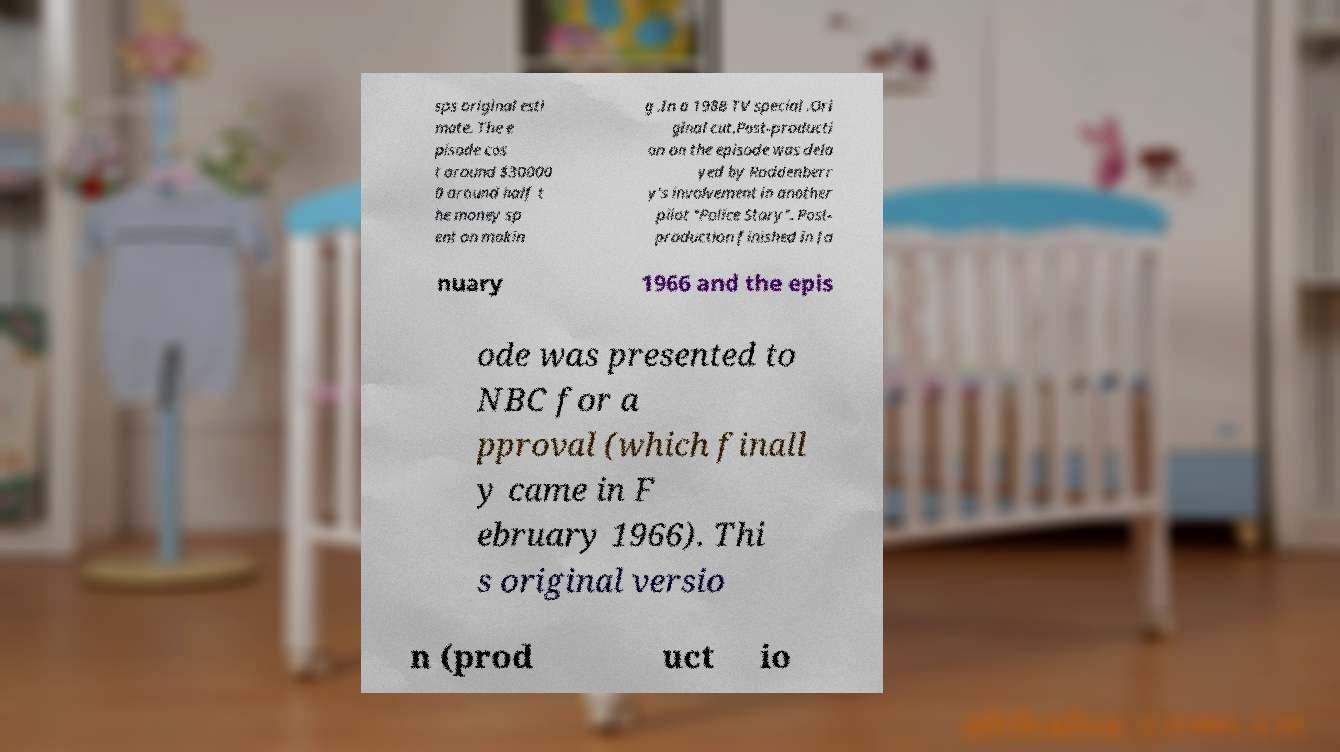Could you extract and type out the text from this image? sps original esti mate. The e pisode cos t around $30000 0 around half t he money sp ent on makin g .In a 1988 TV special .Ori ginal cut.Post-producti on on the episode was dela yed by Roddenberr y's involvement in another pilot "Police Story". Post- production finished in Ja nuary 1966 and the epis ode was presented to NBC for a pproval (which finall y came in F ebruary 1966). Thi s original versio n (prod uct io 